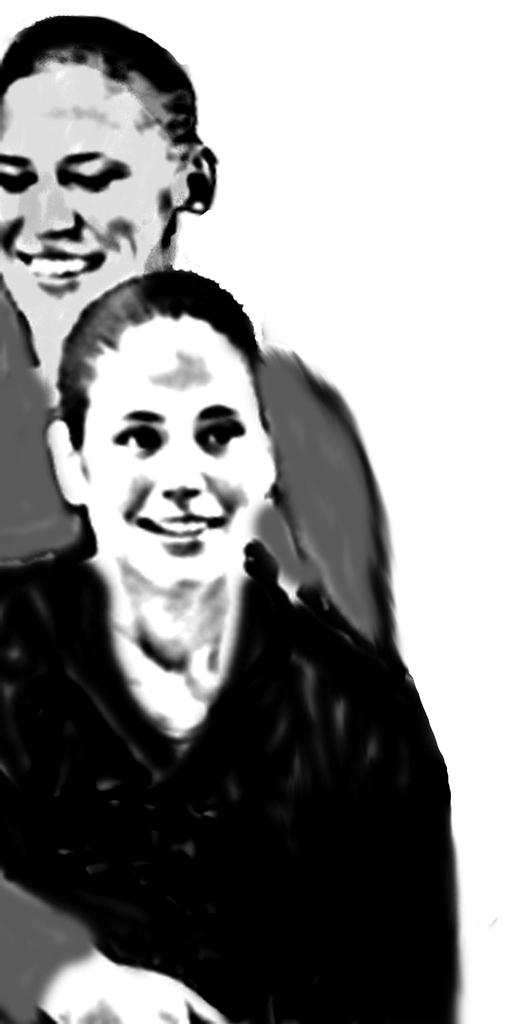How many people are in the image? There are two women in the image. What expressions do the women have? Both women are smiling. What type of grass can be seen growing in the heart of the image? There is no grass or heart present in the image; it features two women who are both smiling. 